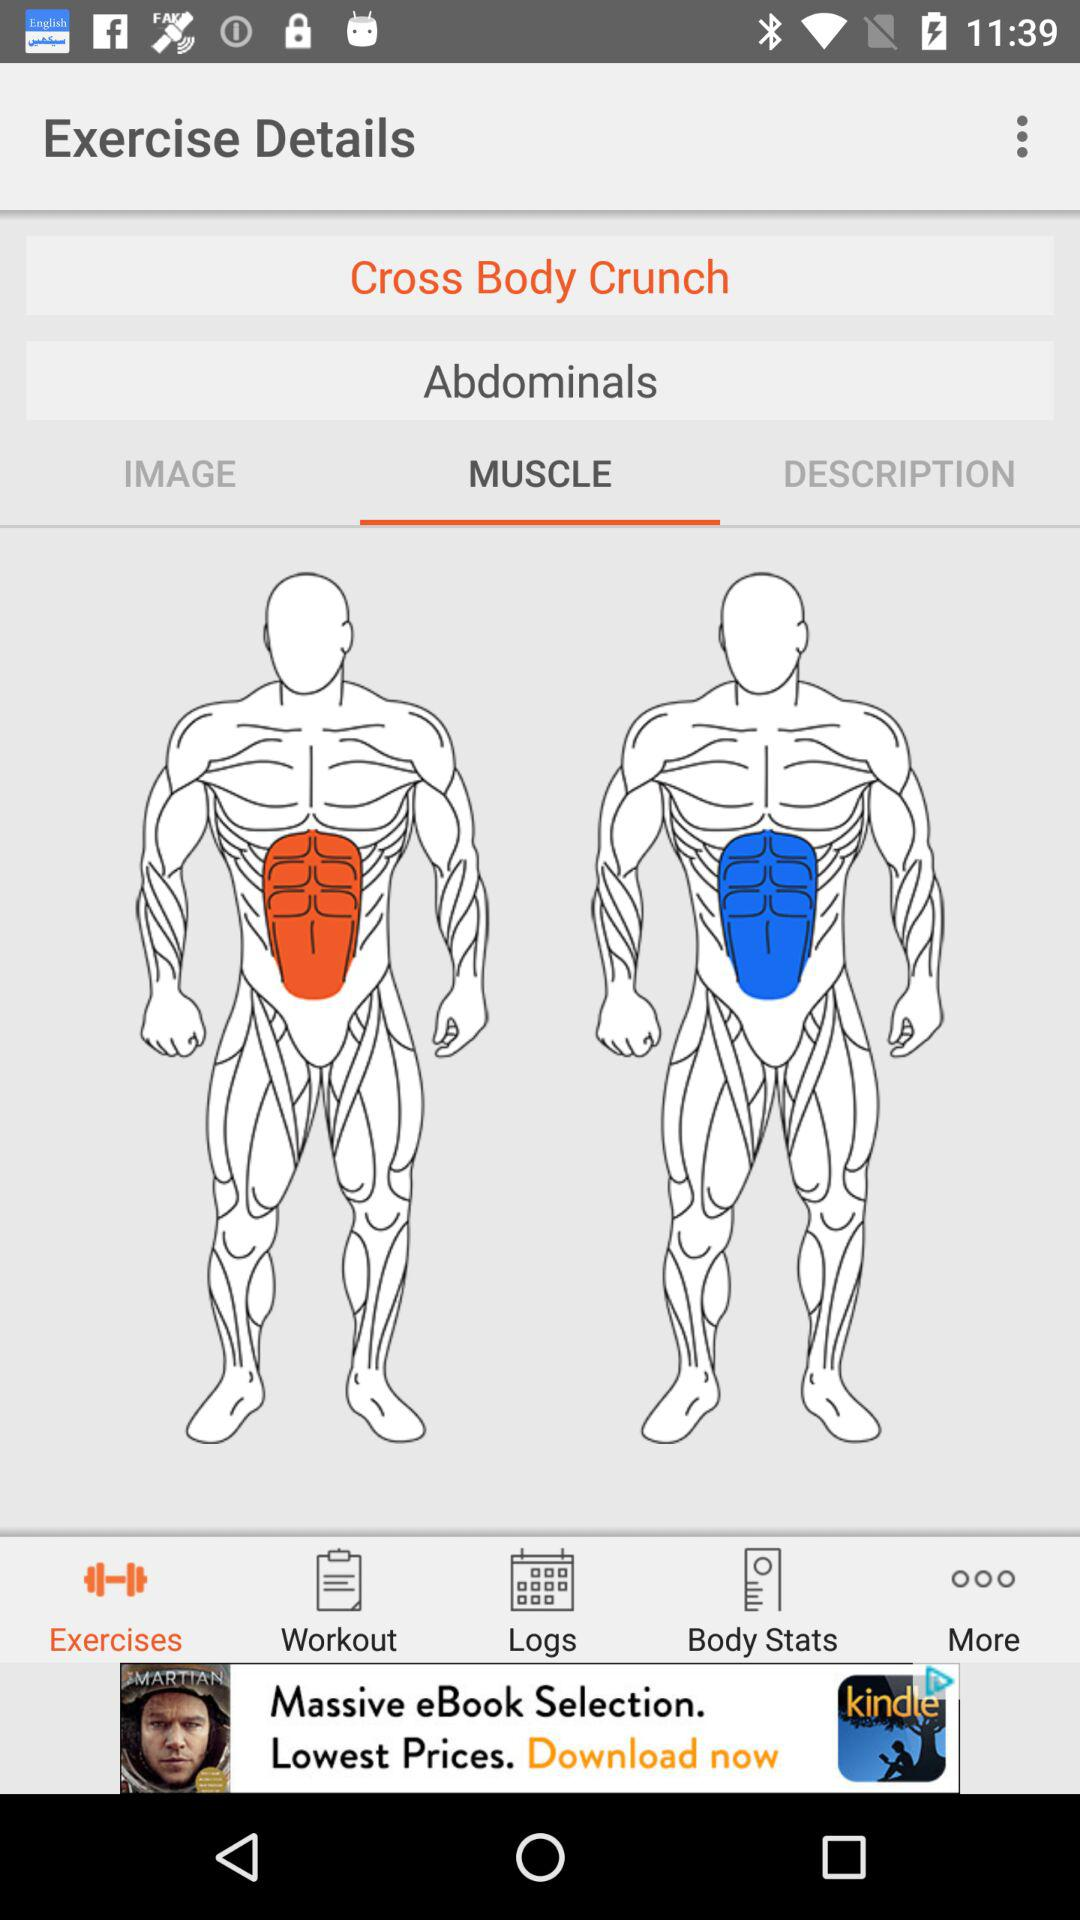What type of muscle exercise is it? It is an abdominal muscle exercise. 